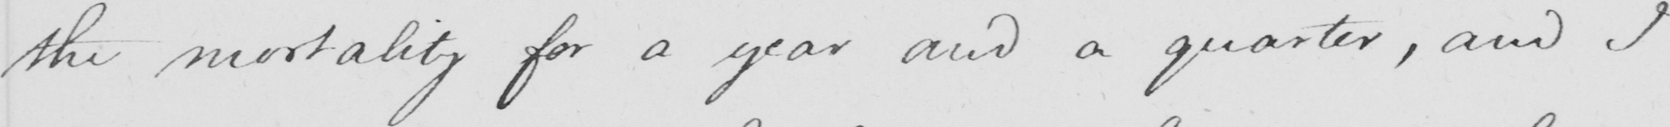Transcribe the text shown in this historical manuscript line. the mortality for a year and a quarter , and I 